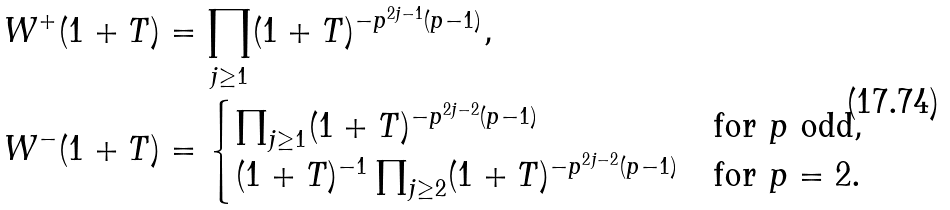<formula> <loc_0><loc_0><loc_500><loc_500>W ^ { + } ( 1 + T ) & = \prod _ { j \geq 1 } ( 1 + T ) ^ { - p ^ { 2 j - 1 } ( p - 1 ) } , \\ W ^ { - } ( 1 + T ) & = \begin{cases} \prod _ { j \geq 1 } ( 1 + T ) ^ { - p ^ { 2 j - 2 } ( p - 1 ) } & \text {for $p$ odd} , \\ ( 1 + T ) ^ { - 1 } \prod _ { j \geq 2 } ( 1 + T ) ^ { - p ^ { 2 j - 2 } ( p - 1 ) } & \text {for $p=2$} . \end{cases}</formula> 